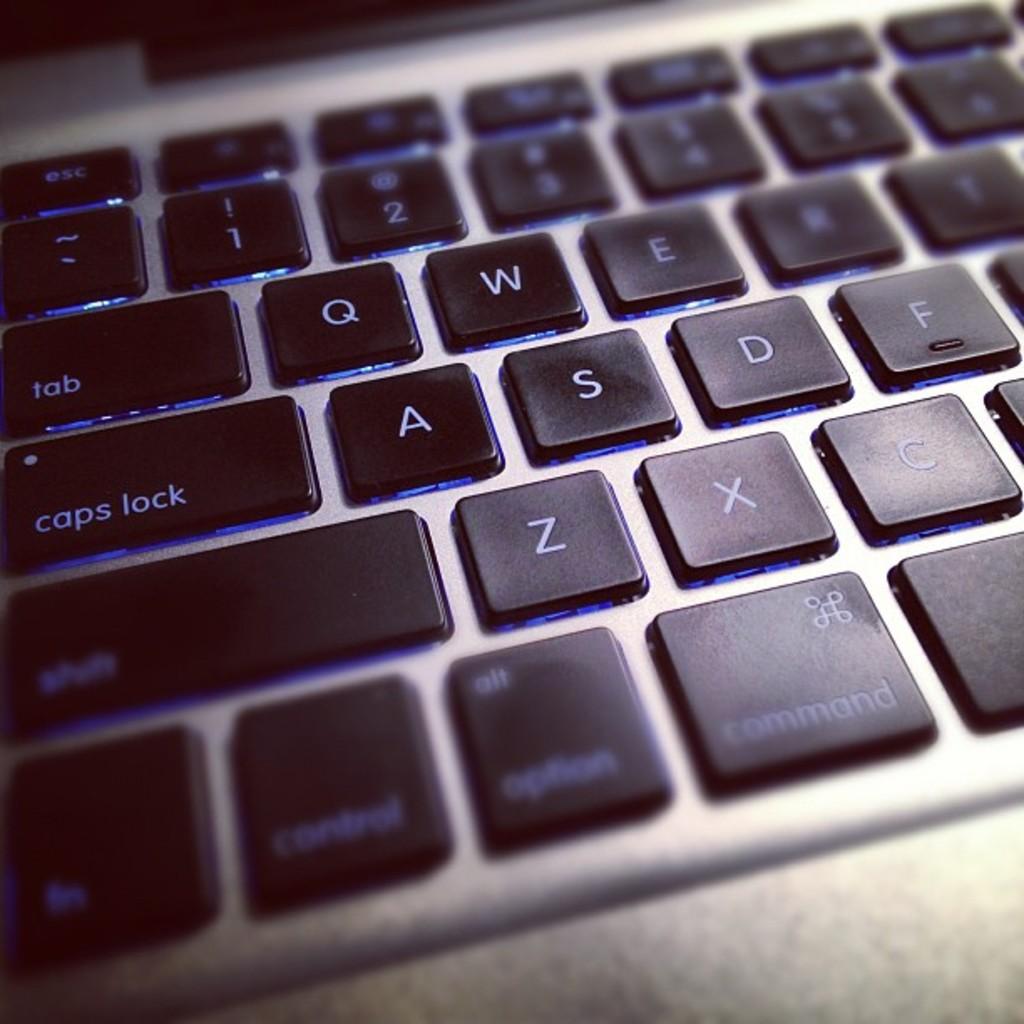What is the key right above the caps lock button?
Give a very brief answer. Tab. Is this the keyboard of a laptop?
Your answer should be very brief. Yes. 